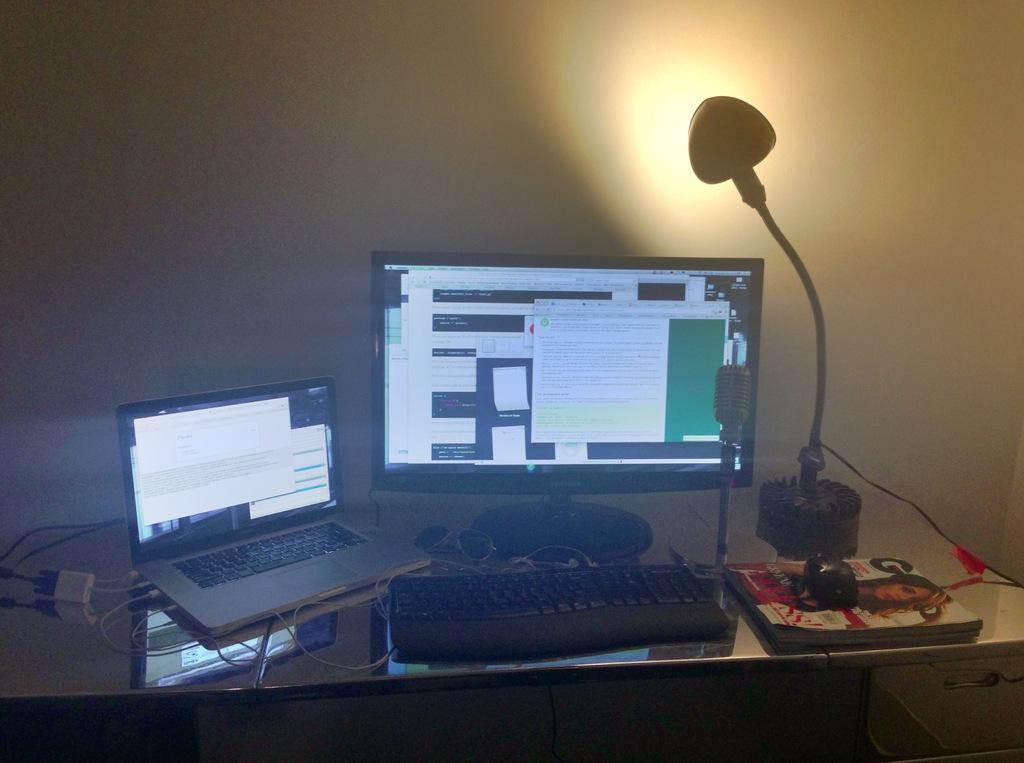<image>
Describe the image concisely. two computer screens on with one of the computers being a macbook 